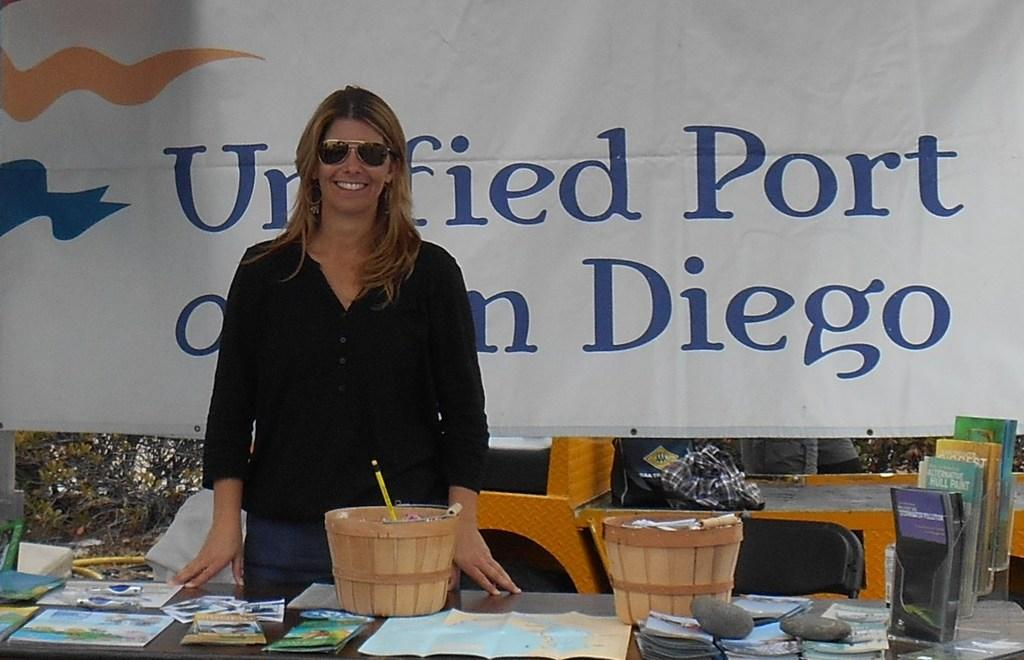Who is present in the image? There is a woman in the image. What is the woman standing in front of? The woman is standing in front of a table. What items can be seen on the table? There are papers, books, and two baskets on the table. What can be seen in the background of the image? There is a banner, books, and trees in the background of the image. What type of cough medicine is recommended in the image? There is no mention of cough medicine or any medical advice in the image. 